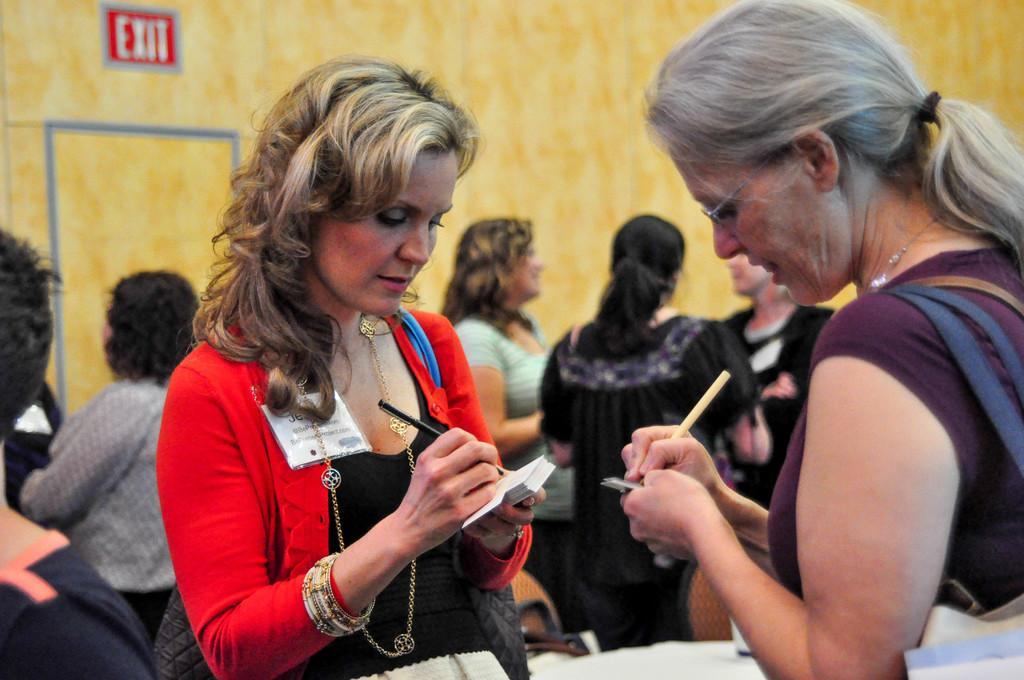How many women are present in the image? There are two women in the image. What are the women holding in their hands? The women are holding pens in their hands. What are the women doing with the pens? The women are writing something. Can you describe the setting in which the women are writing? There are other people in the background of the image. How many apples are being folded in the image? There are no apples present in the image, and therefore no folding of apples is taking place. 